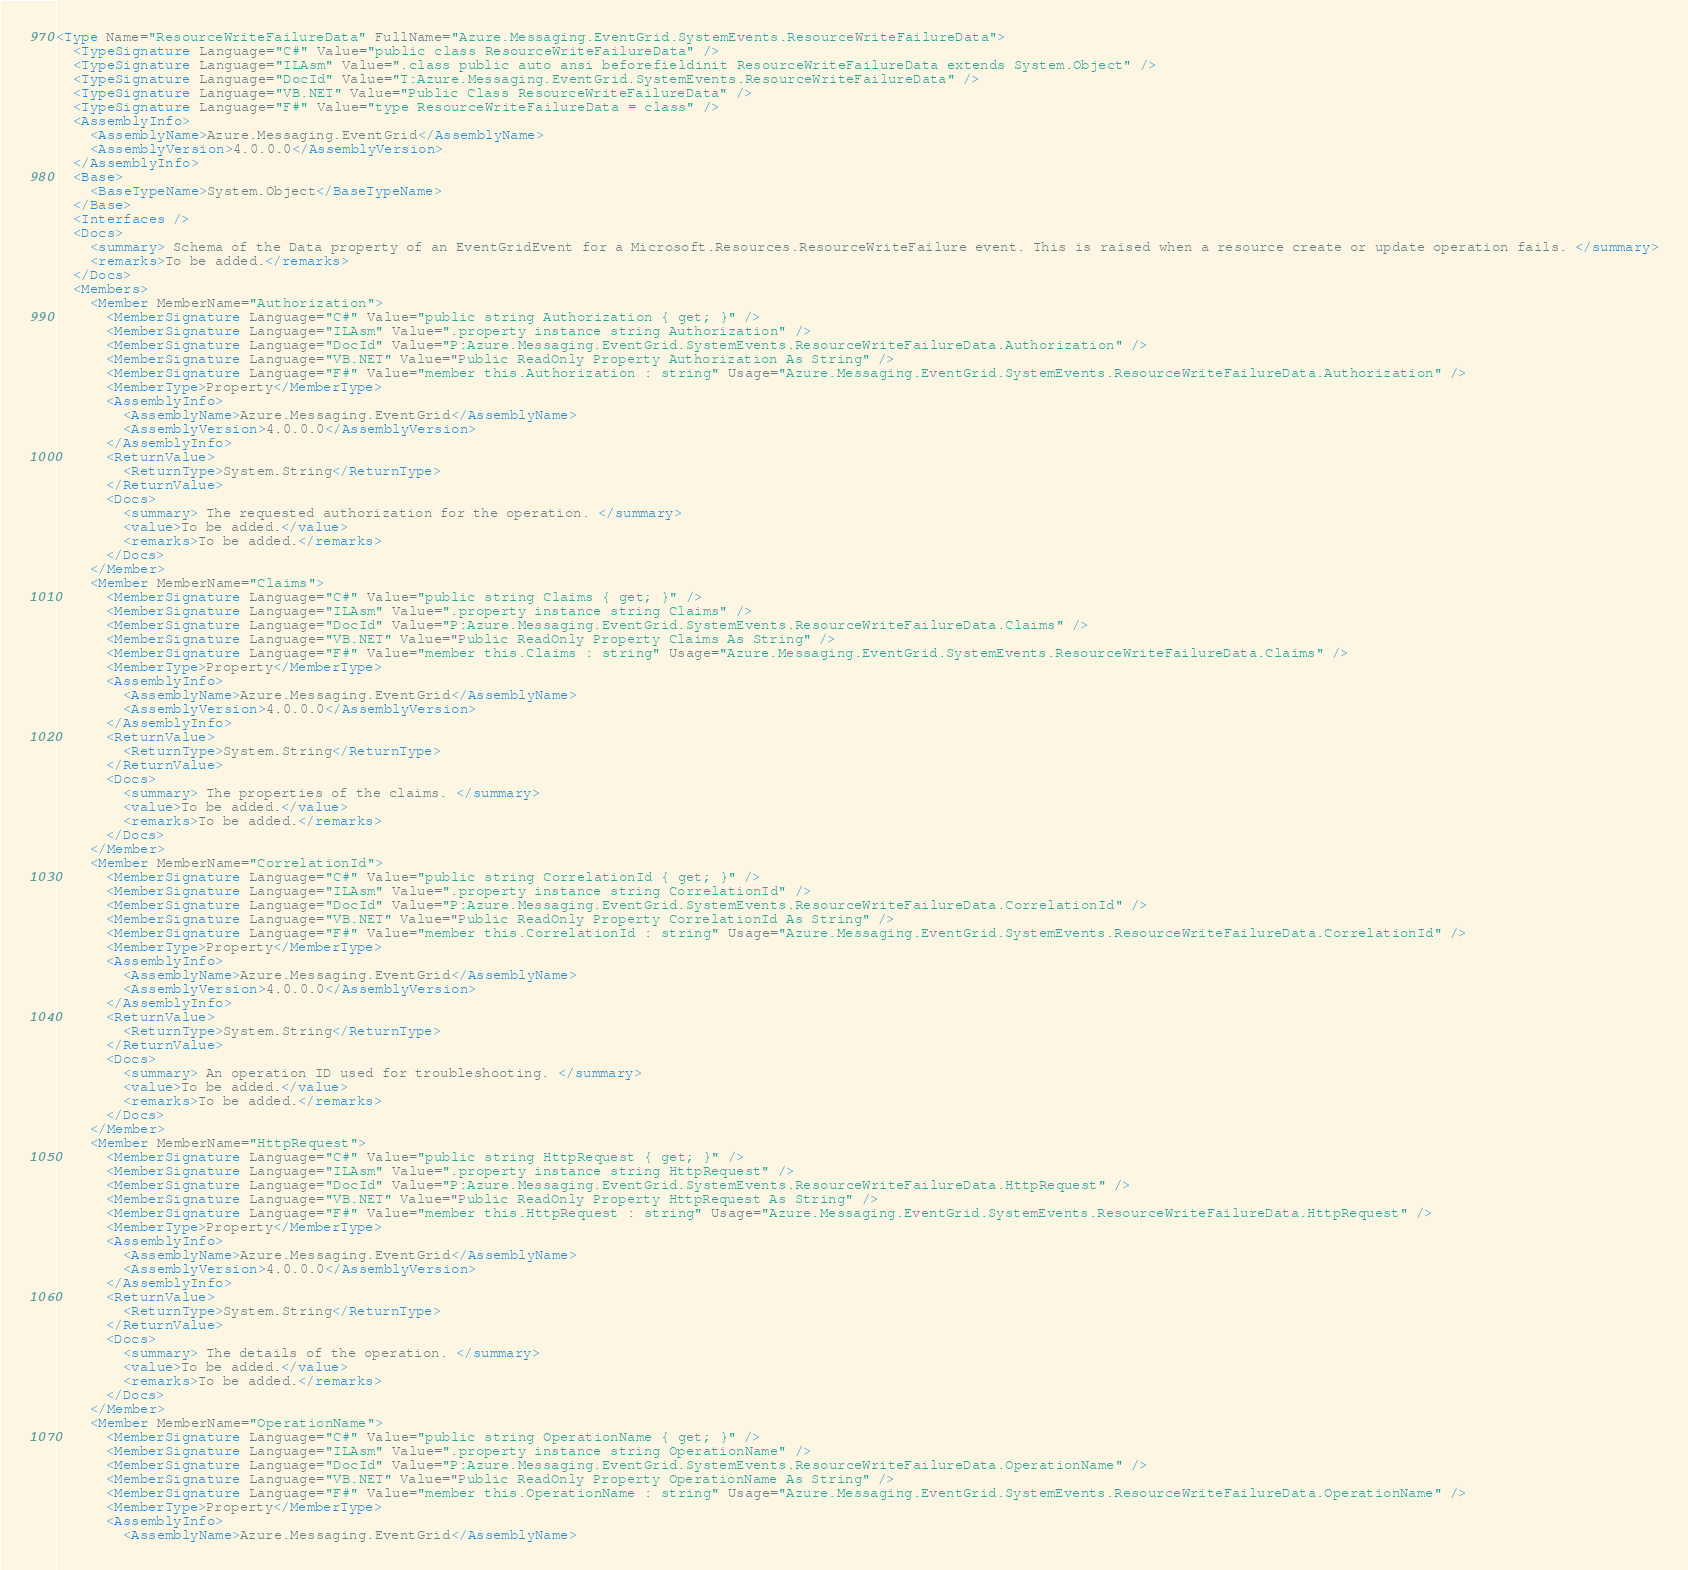Convert code to text. <code><loc_0><loc_0><loc_500><loc_500><_XML_><Type Name="ResourceWriteFailureData" FullName="Azure.Messaging.EventGrid.SystemEvents.ResourceWriteFailureData">
  <TypeSignature Language="C#" Value="public class ResourceWriteFailureData" />
  <TypeSignature Language="ILAsm" Value=".class public auto ansi beforefieldinit ResourceWriteFailureData extends System.Object" />
  <TypeSignature Language="DocId" Value="T:Azure.Messaging.EventGrid.SystemEvents.ResourceWriteFailureData" />
  <TypeSignature Language="VB.NET" Value="Public Class ResourceWriteFailureData" />
  <TypeSignature Language="F#" Value="type ResourceWriteFailureData = class" />
  <AssemblyInfo>
    <AssemblyName>Azure.Messaging.EventGrid</AssemblyName>
    <AssemblyVersion>4.0.0.0</AssemblyVersion>
  </AssemblyInfo>
  <Base>
    <BaseTypeName>System.Object</BaseTypeName>
  </Base>
  <Interfaces />
  <Docs>
    <summary> Schema of the Data property of an EventGridEvent for a Microsoft.Resources.ResourceWriteFailure event. This is raised when a resource create or update operation fails. </summary>
    <remarks>To be added.</remarks>
  </Docs>
  <Members>
    <Member MemberName="Authorization">
      <MemberSignature Language="C#" Value="public string Authorization { get; }" />
      <MemberSignature Language="ILAsm" Value=".property instance string Authorization" />
      <MemberSignature Language="DocId" Value="P:Azure.Messaging.EventGrid.SystemEvents.ResourceWriteFailureData.Authorization" />
      <MemberSignature Language="VB.NET" Value="Public ReadOnly Property Authorization As String" />
      <MemberSignature Language="F#" Value="member this.Authorization : string" Usage="Azure.Messaging.EventGrid.SystemEvents.ResourceWriteFailureData.Authorization" />
      <MemberType>Property</MemberType>
      <AssemblyInfo>
        <AssemblyName>Azure.Messaging.EventGrid</AssemblyName>
        <AssemblyVersion>4.0.0.0</AssemblyVersion>
      </AssemblyInfo>
      <ReturnValue>
        <ReturnType>System.String</ReturnType>
      </ReturnValue>
      <Docs>
        <summary> The requested authorization for the operation. </summary>
        <value>To be added.</value>
        <remarks>To be added.</remarks>
      </Docs>
    </Member>
    <Member MemberName="Claims">
      <MemberSignature Language="C#" Value="public string Claims { get; }" />
      <MemberSignature Language="ILAsm" Value=".property instance string Claims" />
      <MemberSignature Language="DocId" Value="P:Azure.Messaging.EventGrid.SystemEvents.ResourceWriteFailureData.Claims" />
      <MemberSignature Language="VB.NET" Value="Public ReadOnly Property Claims As String" />
      <MemberSignature Language="F#" Value="member this.Claims : string" Usage="Azure.Messaging.EventGrid.SystemEvents.ResourceWriteFailureData.Claims" />
      <MemberType>Property</MemberType>
      <AssemblyInfo>
        <AssemblyName>Azure.Messaging.EventGrid</AssemblyName>
        <AssemblyVersion>4.0.0.0</AssemblyVersion>
      </AssemblyInfo>
      <ReturnValue>
        <ReturnType>System.String</ReturnType>
      </ReturnValue>
      <Docs>
        <summary> The properties of the claims. </summary>
        <value>To be added.</value>
        <remarks>To be added.</remarks>
      </Docs>
    </Member>
    <Member MemberName="CorrelationId">
      <MemberSignature Language="C#" Value="public string CorrelationId { get; }" />
      <MemberSignature Language="ILAsm" Value=".property instance string CorrelationId" />
      <MemberSignature Language="DocId" Value="P:Azure.Messaging.EventGrid.SystemEvents.ResourceWriteFailureData.CorrelationId" />
      <MemberSignature Language="VB.NET" Value="Public ReadOnly Property CorrelationId As String" />
      <MemberSignature Language="F#" Value="member this.CorrelationId : string" Usage="Azure.Messaging.EventGrid.SystemEvents.ResourceWriteFailureData.CorrelationId" />
      <MemberType>Property</MemberType>
      <AssemblyInfo>
        <AssemblyName>Azure.Messaging.EventGrid</AssemblyName>
        <AssemblyVersion>4.0.0.0</AssemblyVersion>
      </AssemblyInfo>
      <ReturnValue>
        <ReturnType>System.String</ReturnType>
      </ReturnValue>
      <Docs>
        <summary> An operation ID used for troubleshooting. </summary>
        <value>To be added.</value>
        <remarks>To be added.</remarks>
      </Docs>
    </Member>
    <Member MemberName="HttpRequest">
      <MemberSignature Language="C#" Value="public string HttpRequest { get; }" />
      <MemberSignature Language="ILAsm" Value=".property instance string HttpRequest" />
      <MemberSignature Language="DocId" Value="P:Azure.Messaging.EventGrid.SystemEvents.ResourceWriteFailureData.HttpRequest" />
      <MemberSignature Language="VB.NET" Value="Public ReadOnly Property HttpRequest As String" />
      <MemberSignature Language="F#" Value="member this.HttpRequest : string" Usage="Azure.Messaging.EventGrid.SystemEvents.ResourceWriteFailureData.HttpRequest" />
      <MemberType>Property</MemberType>
      <AssemblyInfo>
        <AssemblyName>Azure.Messaging.EventGrid</AssemblyName>
        <AssemblyVersion>4.0.0.0</AssemblyVersion>
      </AssemblyInfo>
      <ReturnValue>
        <ReturnType>System.String</ReturnType>
      </ReturnValue>
      <Docs>
        <summary> The details of the operation. </summary>
        <value>To be added.</value>
        <remarks>To be added.</remarks>
      </Docs>
    </Member>
    <Member MemberName="OperationName">
      <MemberSignature Language="C#" Value="public string OperationName { get; }" />
      <MemberSignature Language="ILAsm" Value=".property instance string OperationName" />
      <MemberSignature Language="DocId" Value="P:Azure.Messaging.EventGrid.SystemEvents.ResourceWriteFailureData.OperationName" />
      <MemberSignature Language="VB.NET" Value="Public ReadOnly Property OperationName As String" />
      <MemberSignature Language="F#" Value="member this.OperationName : string" Usage="Azure.Messaging.EventGrid.SystemEvents.ResourceWriteFailureData.OperationName" />
      <MemberType>Property</MemberType>
      <AssemblyInfo>
        <AssemblyName>Azure.Messaging.EventGrid</AssemblyName></code> 